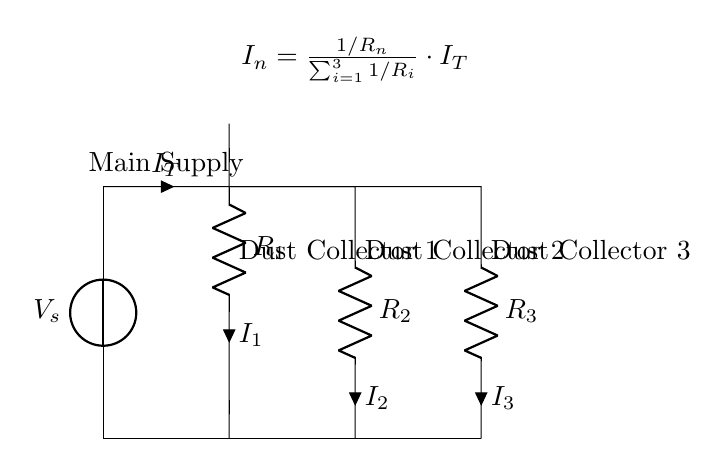What is the total current entering the circuit? The total current is represented by the symbol "I_T" in the circuit diagram, which denotes the sum of currents flowing through all parallel branches.
Answer: I_T What type of circuit is shown in this diagram? The diagram illustrates a parallel circuit design, where multiple branches allow for different paths for current flow, indicating that each dust collector operates independently.
Answer: Parallel circuit How many dust collectors are connected in parallel? The circuit diagram shows three distinct resistors labeled as dust collectors, indicating that there are three dust collectors connected in parallel.
Answer: Three What is the formula for calculating current through each resistor? The formula provided in the circuit diagram illustrates how to calculate the current in any of the parallel branches: I_n is equal to the product of the inverse of the resistor value and the total current divided by the sum of the inverses of all resistor values.
Answer: I_n = \frac{1/R_n}{\sum_{i=1}^{3} 1/R_i} \cdot I_T Which component has the label R_2? The component labeled "R_2" refers to the second resistor in the parallel circuit, representing the second dust collector in the system.
Answer: Dust Collector 2 What is the function of the ground connection in this circuit? The ground connection provides a common return path for the current to flow back to the source, establishing a reference point for the circuit and ensuring system stability.
Answer: Reference point 